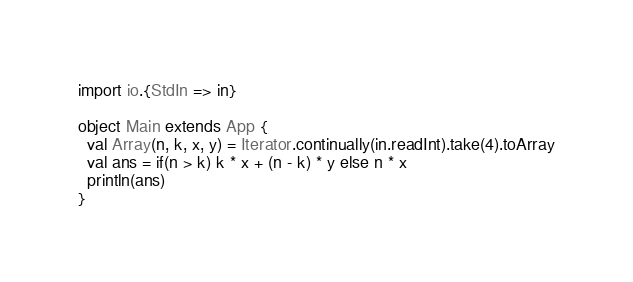Convert code to text. <code><loc_0><loc_0><loc_500><loc_500><_Scala_>import io.{StdIn => in}

object Main extends App {
  val Array(n, k, x, y) = Iterator.continually(in.readInt).take(4).toArray
  val ans = if(n > k) k * x + (n - k) * y else n * x
  println(ans)
}</code> 